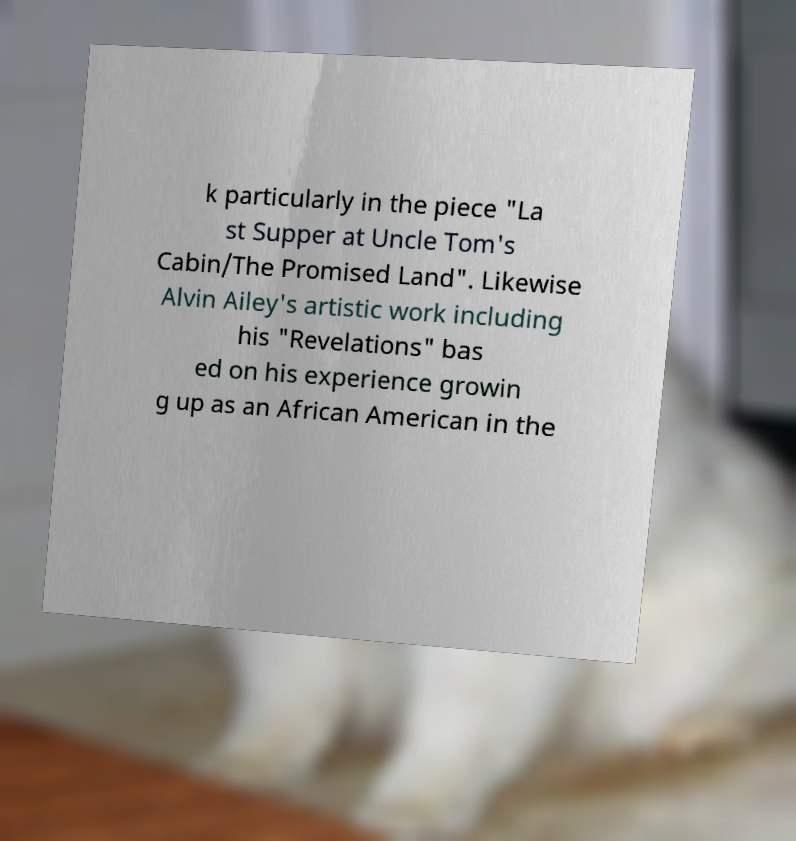Could you extract and type out the text from this image? k particularly in the piece "La st Supper at Uncle Tom's Cabin/The Promised Land". Likewise Alvin Ailey's artistic work including his "Revelations" bas ed on his experience growin g up as an African American in the 